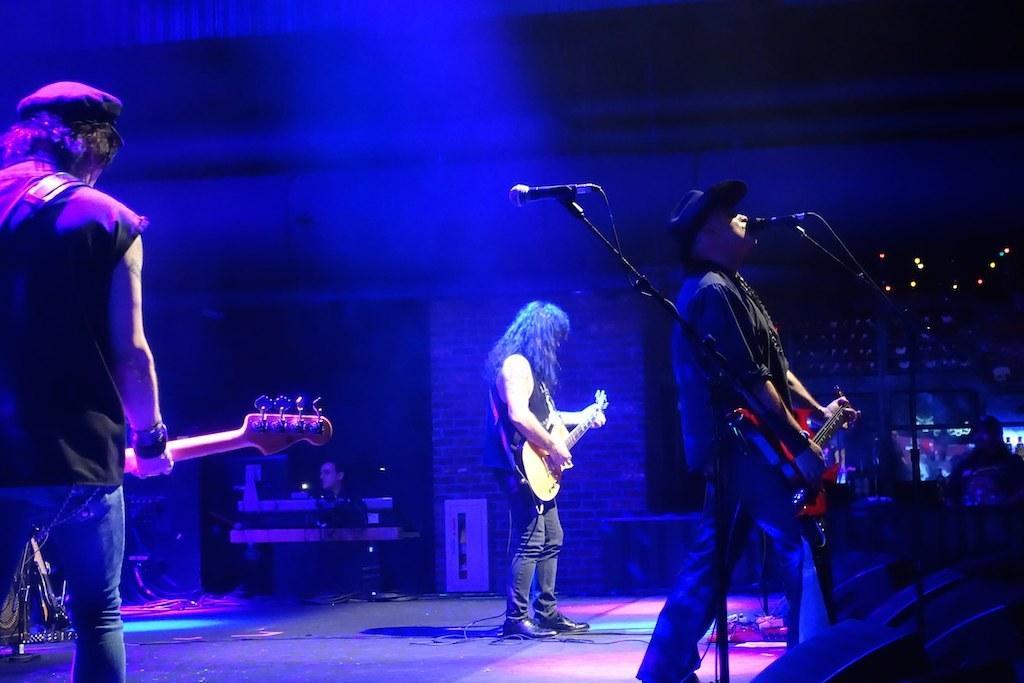In one or two sentences, can you explain what this image depicts? In this image there are group of people, there are three people standing in front of the microphones and playing guitar. At the bottom there are wires and speakers. 